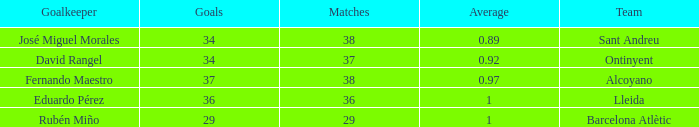Could you parse the entire table as a dict? {'header': ['Goalkeeper', 'Goals', 'Matches', 'Average', 'Team'], 'rows': [['José Miguel Morales', '34', '38', '0.89', 'Sant Andreu'], ['David Rangel', '34', '37', '0.92', 'Ontinyent'], ['Fernando Maestro', '37', '38', '0.97', 'Alcoyano'], ['Eduardo Pérez', '36', '36', '1', 'Lleida'], ['Rubén Miño', '29', '29', '1', 'Barcelona Atlètic']]} What is the sum of Goals, when Matches is less than 29? None. 